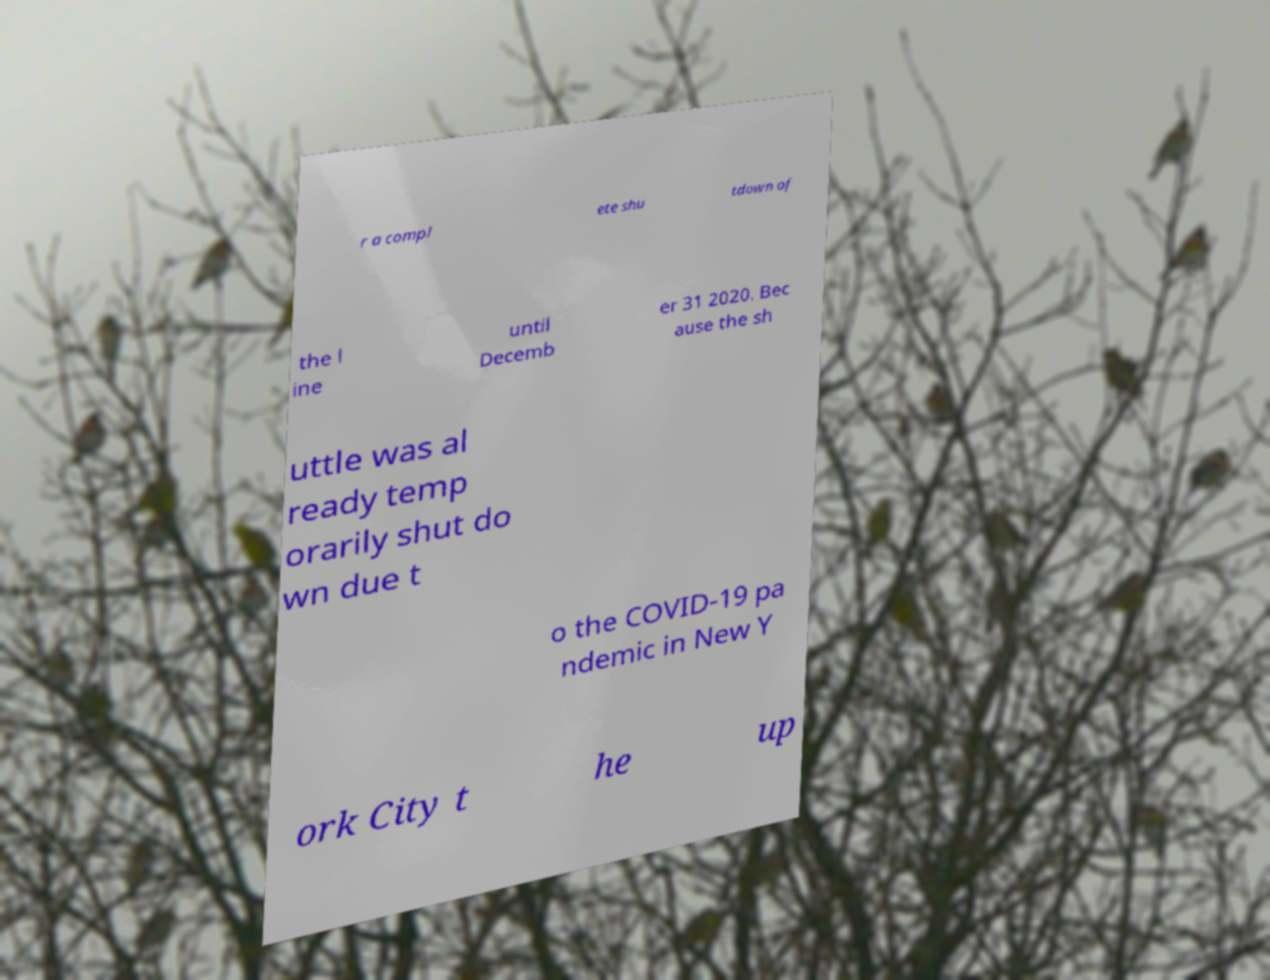I need the written content from this picture converted into text. Can you do that? r a compl ete shu tdown of the l ine until Decemb er 31 2020. Bec ause the sh uttle was al ready temp orarily shut do wn due t o the COVID-19 pa ndemic in New Y ork City t he up 